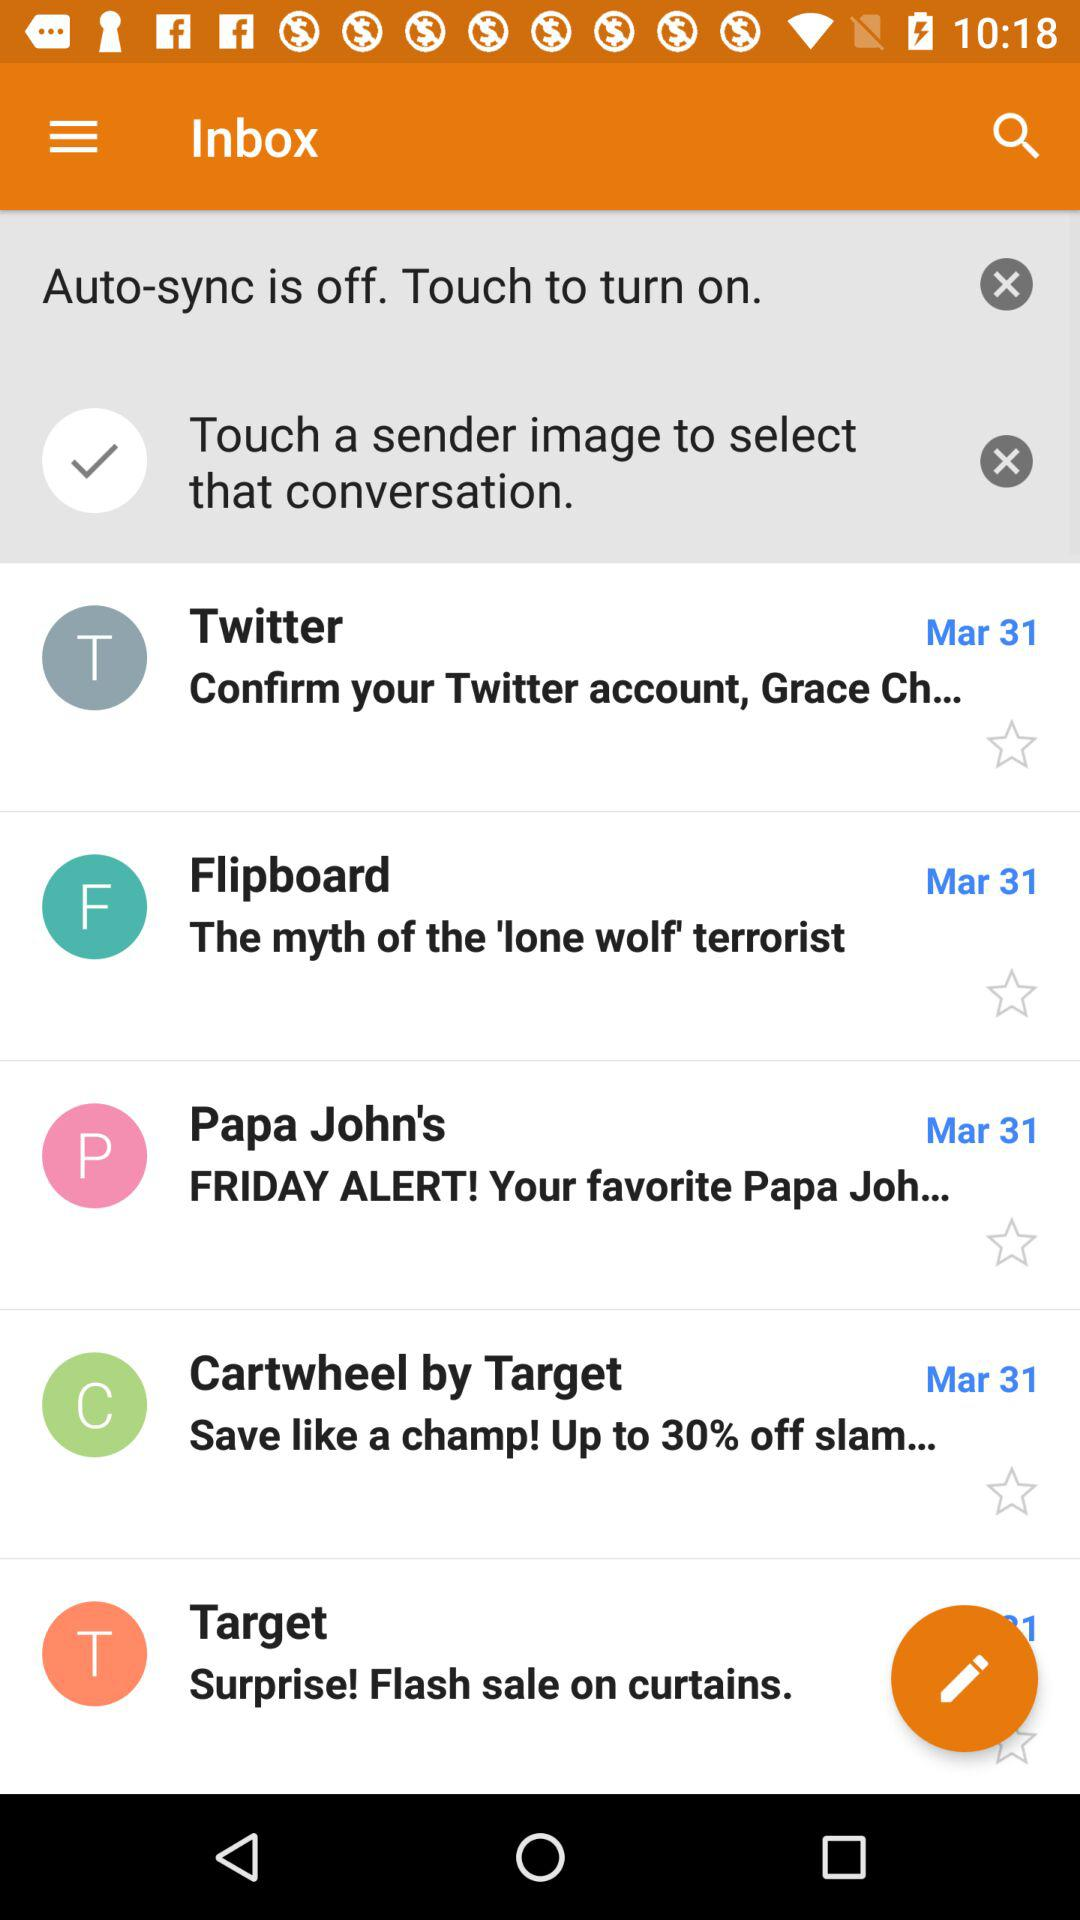How to on Auto-sync?
When the provided information is insufficient, respond with <no answer>. <no answer> 